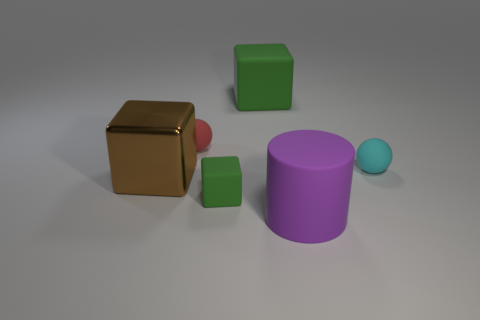Subtract all metallic cubes. How many cubes are left? 2 Add 4 cyan rubber objects. How many objects exist? 10 Subtract all spheres. How many objects are left? 4 Subtract 1 spheres. How many spheres are left? 1 Subtract all gray balls. Subtract all red cylinders. How many balls are left? 2 Subtract all purple cylinders. How many green cubes are left? 2 Subtract all tiny cyan rubber objects. Subtract all metal blocks. How many objects are left? 4 Add 4 large purple rubber cylinders. How many large purple rubber cylinders are left? 5 Add 5 big blue shiny objects. How many big blue shiny objects exist? 5 Subtract all brown blocks. How many blocks are left? 2 